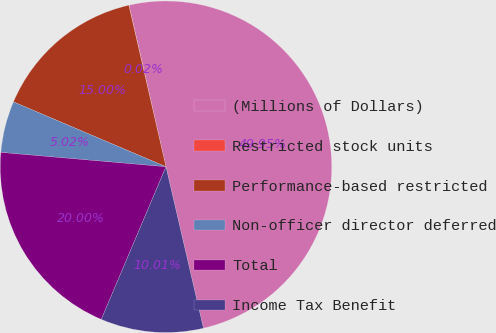Convert chart to OTSL. <chart><loc_0><loc_0><loc_500><loc_500><pie_chart><fcel>(Millions of Dollars)<fcel>Restricted stock units<fcel>Performance-based restricted<fcel>Non-officer director deferred<fcel>Total<fcel>Income Tax Benefit<nl><fcel>49.95%<fcel>0.02%<fcel>15.0%<fcel>5.02%<fcel>20.0%<fcel>10.01%<nl></chart> 